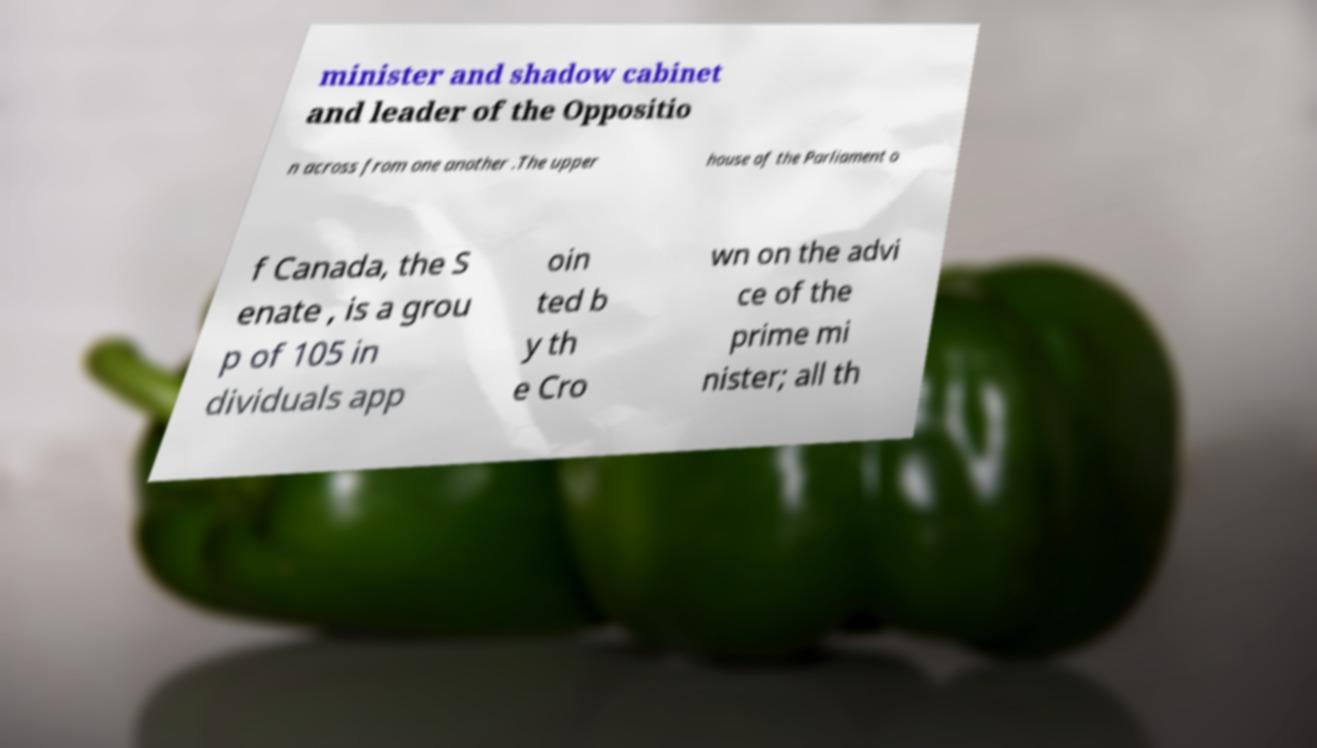Could you extract and type out the text from this image? minister and shadow cabinet and leader of the Oppositio n across from one another .The upper house of the Parliament o f Canada, the S enate , is a grou p of 105 in dividuals app oin ted b y th e Cro wn on the advi ce of the prime mi nister; all th 